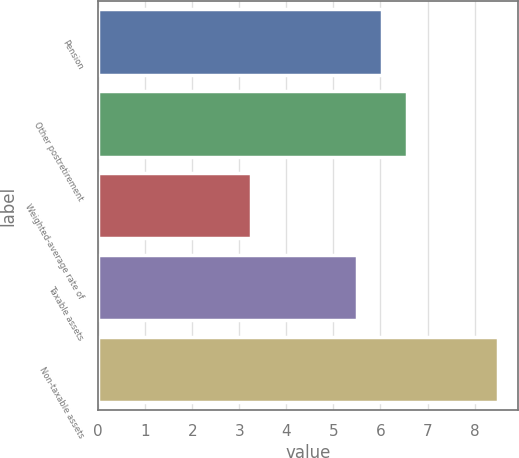Convert chart to OTSL. <chart><loc_0><loc_0><loc_500><loc_500><bar_chart><fcel>Pension<fcel>Other postretirement<fcel>Weighted-average rate of<fcel>Taxable assets<fcel>Non-taxable assets<nl><fcel>6.03<fcel>6.56<fcel>3.25<fcel>5.5<fcel>8.5<nl></chart> 